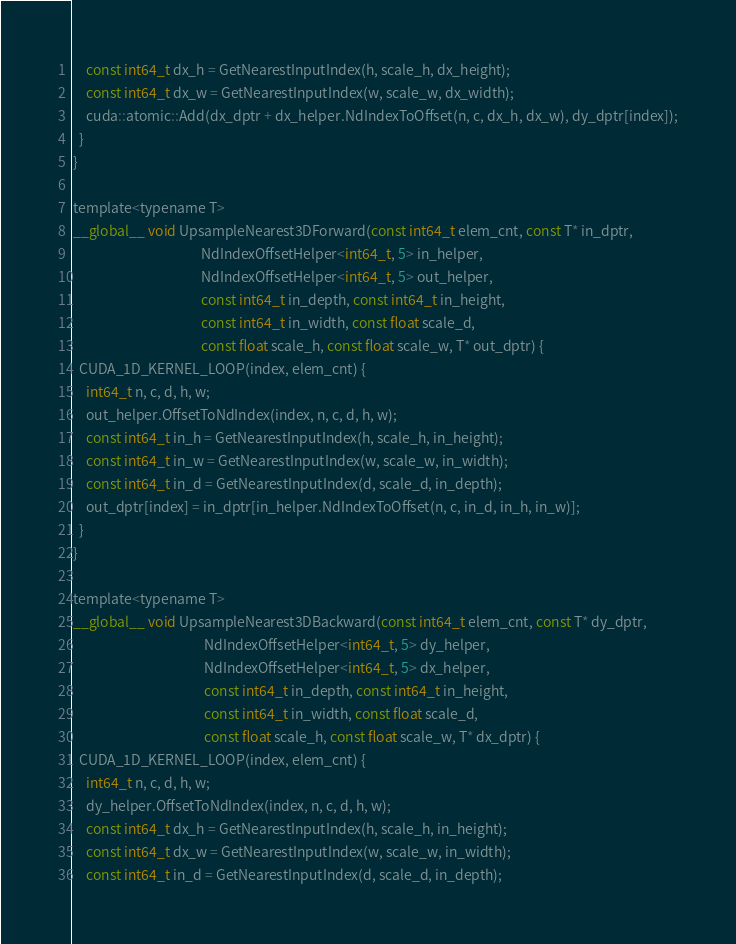<code> <loc_0><loc_0><loc_500><loc_500><_Cuda_>    const int64_t dx_h = GetNearestInputIndex(h, scale_h, dx_height);
    const int64_t dx_w = GetNearestInputIndex(w, scale_w, dx_width);
    cuda::atomic::Add(dx_dptr + dx_helper.NdIndexToOffset(n, c, dx_h, dx_w), dy_dptr[index]);
  }
}

template<typename T>
__global__ void UpsampleNearest3DForward(const int64_t elem_cnt, const T* in_dptr,
                                         NdIndexOffsetHelper<int64_t, 5> in_helper,
                                         NdIndexOffsetHelper<int64_t, 5> out_helper,
                                         const int64_t in_depth, const int64_t in_height,
                                         const int64_t in_width, const float scale_d,
                                         const float scale_h, const float scale_w, T* out_dptr) {
  CUDA_1D_KERNEL_LOOP(index, elem_cnt) {
    int64_t n, c, d, h, w;
    out_helper.OffsetToNdIndex(index, n, c, d, h, w);
    const int64_t in_h = GetNearestInputIndex(h, scale_h, in_height);
    const int64_t in_w = GetNearestInputIndex(w, scale_w, in_width);
    const int64_t in_d = GetNearestInputIndex(d, scale_d, in_depth);
    out_dptr[index] = in_dptr[in_helper.NdIndexToOffset(n, c, in_d, in_h, in_w)];
  }
}

template<typename T>
__global__ void UpsampleNearest3DBackward(const int64_t elem_cnt, const T* dy_dptr,
                                          NdIndexOffsetHelper<int64_t, 5> dy_helper,
                                          NdIndexOffsetHelper<int64_t, 5> dx_helper,
                                          const int64_t in_depth, const int64_t in_height,
                                          const int64_t in_width, const float scale_d,
                                          const float scale_h, const float scale_w, T* dx_dptr) {
  CUDA_1D_KERNEL_LOOP(index, elem_cnt) {
    int64_t n, c, d, h, w;
    dy_helper.OffsetToNdIndex(index, n, c, d, h, w);
    const int64_t dx_h = GetNearestInputIndex(h, scale_h, in_height);
    const int64_t dx_w = GetNearestInputIndex(w, scale_w, in_width);
    const int64_t in_d = GetNearestInputIndex(d, scale_d, in_depth);</code> 